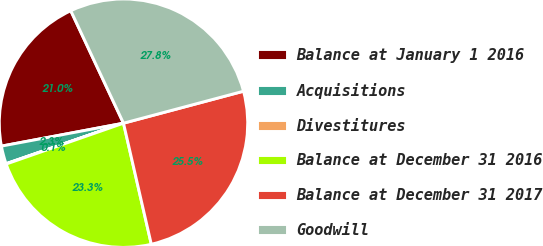Convert chart to OTSL. <chart><loc_0><loc_0><loc_500><loc_500><pie_chart><fcel>Balance at January 1 2016<fcel>Acquisitions<fcel>Divestitures<fcel>Balance at December 31 2016<fcel>Balance at December 31 2017<fcel>Goodwill<nl><fcel>20.98%<fcel>2.33%<fcel>0.05%<fcel>23.26%<fcel>25.55%<fcel>27.83%<nl></chart> 